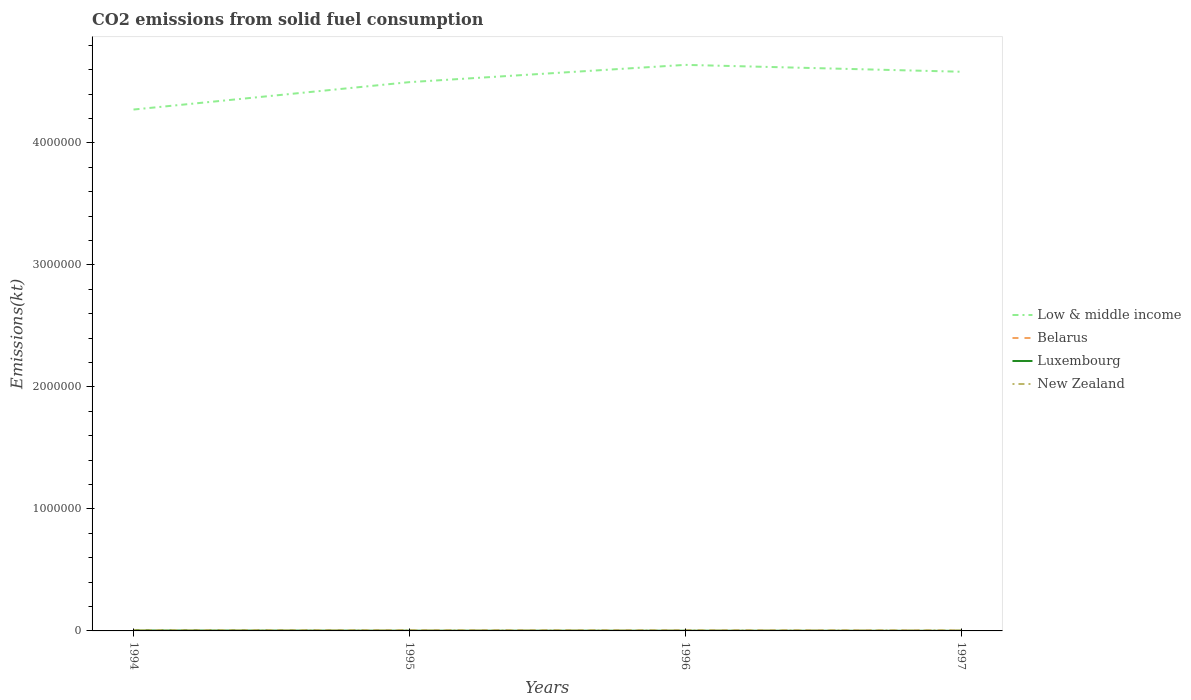Does the line corresponding to Luxembourg intersect with the line corresponding to Belarus?
Ensure brevity in your answer.  No. Across all years, what is the maximum amount of CO2 emitted in Belarus?
Give a very brief answer. 4140.04. In which year was the amount of CO2 emitted in Belarus maximum?
Provide a succinct answer. 1997. What is the total amount of CO2 emitted in Low & middle income in the graph?
Keep it short and to the point. -3.10e+05. What is the difference between the highest and the second highest amount of CO2 emitted in Belarus?
Keep it short and to the point. 1789.5. How many lines are there?
Give a very brief answer. 4. How many years are there in the graph?
Keep it short and to the point. 4. What is the difference between two consecutive major ticks on the Y-axis?
Ensure brevity in your answer.  1.00e+06. Are the values on the major ticks of Y-axis written in scientific E-notation?
Make the answer very short. No. How many legend labels are there?
Your answer should be very brief. 4. What is the title of the graph?
Your answer should be compact. CO2 emissions from solid fuel consumption. Does "Gabon" appear as one of the legend labels in the graph?
Make the answer very short. No. What is the label or title of the X-axis?
Give a very brief answer. Years. What is the label or title of the Y-axis?
Your answer should be compact. Emissions(kt). What is the Emissions(kt) of Low & middle income in 1994?
Provide a succinct answer. 4.27e+06. What is the Emissions(kt) in Belarus in 1994?
Provide a short and direct response. 5929.54. What is the Emissions(kt) of Luxembourg in 1994?
Provide a short and direct response. 3432.31. What is the Emissions(kt) in New Zealand in 1994?
Offer a very short reply. 4602.09. What is the Emissions(kt) in Low & middle income in 1995?
Provide a succinct answer. 4.50e+06. What is the Emissions(kt) in Belarus in 1995?
Keep it short and to the point. 5291.48. What is the Emissions(kt) of Luxembourg in 1995?
Your answer should be very brief. 1947.18. What is the Emissions(kt) of New Zealand in 1995?
Provide a succinct answer. 4462.74. What is the Emissions(kt) of Low & middle income in 1996?
Ensure brevity in your answer.  4.64e+06. What is the Emissions(kt) in Belarus in 1996?
Your answer should be very brief. 5038.46. What is the Emissions(kt) of Luxembourg in 1996?
Offer a terse response. 1840.83. What is the Emissions(kt) of New Zealand in 1996?
Ensure brevity in your answer.  3652.33. What is the Emissions(kt) in Low & middle income in 1997?
Your answer should be compact. 4.58e+06. What is the Emissions(kt) of Belarus in 1997?
Your answer should be very brief. 4140.04. What is the Emissions(kt) of Luxembourg in 1997?
Keep it short and to the point. 1184.44. What is the Emissions(kt) in New Zealand in 1997?
Offer a terse response. 4543.41. Across all years, what is the maximum Emissions(kt) in Low & middle income?
Give a very brief answer. 4.64e+06. Across all years, what is the maximum Emissions(kt) in Belarus?
Your answer should be very brief. 5929.54. Across all years, what is the maximum Emissions(kt) of Luxembourg?
Offer a terse response. 3432.31. Across all years, what is the maximum Emissions(kt) of New Zealand?
Your response must be concise. 4602.09. Across all years, what is the minimum Emissions(kt) in Low & middle income?
Ensure brevity in your answer.  4.27e+06. Across all years, what is the minimum Emissions(kt) of Belarus?
Your answer should be very brief. 4140.04. Across all years, what is the minimum Emissions(kt) in Luxembourg?
Provide a short and direct response. 1184.44. Across all years, what is the minimum Emissions(kt) of New Zealand?
Provide a short and direct response. 3652.33. What is the total Emissions(kt) of Low & middle income in the graph?
Ensure brevity in your answer.  1.80e+07. What is the total Emissions(kt) of Belarus in the graph?
Your answer should be compact. 2.04e+04. What is the total Emissions(kt) in Luxembourg in the graph?
Provide a short and direct response. 8404.76. What is the total Emissions(kt) in New Zealand in the graph?
Make the answer very short. 1.73e+04. What is the difference between the Emissions(kt) in Low & middle income in 1994 and that in 1995?
Make the answer very short. -2.25e+05. What is the difference between the Emissions(kt) of Belarus in 1994 and that in 1995?
Provide a succinct answer. 638.06. What is the difference between the Emissions(kt) of Luxembourg in 1994 and that in 1995?
Give a very brief answer. 1485.13. What is the difference between the Emissions(kt) of New Zealand in 1994 and that in 1995?
Offer a terse response. 139.35. What is the difference between the Emissions(kt) of Low & middle income in 1994 and that in 1996?
Offer a terse response. -3.66e+05. What is the difference between the Emissions(kt) of Belarus in 1994 and that in 1996?
Your response must be concise. 891.08. What is the difference between the Emissions(kt) of Luxembourg in 1994 and that in 1996?
Your answer should be very brief. 1591.48. What is the difference between the Emissions(kt) of New Zealand in 1994 and that in 1996?
Offer a terse response. 949.75. What is the difference between the Emissions(kt) in Low & middle income in 1994 and that in 1997?
Your answer should be compact. -3.10e+05. What is the difference between the Emissions(kt) in Belarus in 1994 and that in 1997?
Give a very brief answer. 1789.5. What is the difference between the Emissions(kt) of Luxembourg in 1994 and that in 1997?
Offer a very short reply. 2247.87. What is the difference between the Emissions(kt) in New Zealand in 1994 and that in 1997?
Your response must be concise. 58.67. What is the difference between the Emissions(kt) in Low & middle income in 1995 and that in 1996?
Provide a short and direct response. -1.42e+05. What is the difference between the Emissions(kt) of Belarus in 1995 and that in 1996?
Provide a succinct answer. 253.02. What is the difference between the Emissions(kt) in Luxembourg in 1995 and that in 1996?
Your answer should be very brief. 106.34. What is the difference between the Emissions(kt) of New Zealand in 1995 and that in 1996?
Provide a short and direct response. 810.41. What is the difference between the Emissions(kt) in Low & middle income in 1995 and that in 1997?
Your answer should be very brief. -8.53e+04. What is the difference between the Emissions(kt) of Belarus in 1995 and that in 1997?
Offer a terse response. 1151.44. What is the difference between the Emissions(kt) in Luxembourg in 1995 and that in 1997?
Provide a succinct answer. 762.74. What is the difference between the Emissions(kt) of New Zealand in 1995 and that in 1997?
Make the answer very short. -80.67. What is the difference between the Emissions(kt) in Low & middle income in 1996 and that in 1997?
Offer a very short reply. 5.63e+04. What is the difference between the Emissions(kt) of Belarus in 1996 and that in 1997?
Provide a succinct answer. 898.41. What is the difference between the Emissions(kt) of Luxembourg in 1996 and that in 1997?
Give a very brief answer. 656.39. What is the difference between the Emissions(kt) of New Zealand in 1996 and that in 1997?
Your answer should be compact. -891.08. What is the difference between the Emissions(kt) of Low & middle income in 1994 and the Emissions(kt) of Belarus in 1995?
Offer a terse response. 4.27e+06. What is the difference between the Emissions(kt) in Low & middle income in 1994 and the Emissions(kt) in Luxembourg in 1995?
Ensure brevity in your answer.  4.27e+06. What is the difference between the Emissions(kt) of Low & middle income in 1994 and the Emissions(kt) of New Zealand in 1995?
Keep it short and to the point. 4.27e+06. What is the difference between the Emissions(kt) of Belarus in 1994 and the Emissions(kt) of Luxembourg in 1995?
Keep it short and to the point. 3982.36. What is the difference between the Emissions(kt) in Belarus in 1994 and the Emissions(kt) in New Zealand in 1995?
Give a very brief answer. 1466.8. What is the difference between the Emissions(kt) of Luxembourg in 1994 and the Emissions(kt) of New Zealand in 1995?
Offer a very short reply. -1030.43. What is the difference between the Emissions(kt) of Low & middle income in 1994 and the Emissions(kt) of Belarus in 1996?
Ensure brevity in your answer.  4.27e+06. What is the difference between the Emissions(kt) in Low & middle income in 1994 and the Emissions(kt) in Luxembourg in 1996?
Provide a short and direct response. 4.27e+06. What is the difference between the Emissions(kt) of Low & middle income in 1994 and the Emissions(kt) of New Zealand in 1996?
Your response must be concise. 4.27e+06. What is the difference between the Emissions(kt) in Belarus in 1994 and the Emissions(kt) in Luxembourg in 1996?
Your response must be concise. 4088.7. What is the difference between the Emissions(kt) in Belarus in 1994 and the Emissions(kt) in New Zealand in 1996?
Ensure brevity in your answer.  2277.21. What is the difference between the Emissions(kt) of Luxembourg in 1994 and the Emissions(kt) of New Zealand in 1996?
Provide a short and direct response. -220.02. What is the difference between the Emissions(kt) of Low & middle income in 1994 and the Emissions(kt) of Belarus in 1997?
Offer a very short reply. 4.27e+06. What is the difference between the Emissions(kt) of Low & middle income in 1994 and the Emissions(kt) of Luxembourg in 1997?
Offer a very short reply. 4.27e+06. What is the difference between the Emissions(kt) in Low & middle income in 1994 and the Emissions(kt) in New Zealand in 1997?
Give a very brief answer. 4.27e+06. What is the difference between the Emissions(kt) in Belarus in 1994 and the Emissions(kt) in Luxembourg in 1997?
Your response must be concise. 4745.1. What is the difference between the Emissions(kt) of Belarus in 1994 and the Emissions(kt) of New Zealand in 1997?
Provide a succinct answer. 1386.13. What is the difference between the Emissions(kt) in Luxembourg in 1994 and the Emissions(kt) in New Zealand in 1997?
Ensure brevity in your answer.  -1111.1. What is the difference between the Emissions(kt) in Low & middle income in 1995 and the Emissions(kt) in Belarus in 1996?
Offer a terse response. 4.49e+06. What is the difference between the Emissions(kt) of Low & middle income in 1995 and the Emissions(kt) of Luxembourg in 1996?
Provide a succinct answer. 4.50e+06. What is the difference between the Emissions(kt) in Low & middle income in 1995 and the Emissions(kt) in New Zealand in 1996?
Provide a succinct answer. 4.49e+06. What is the difference between the Emissions(kt) of Belarus in 1995 and the Emissions(kt) of Luxembourg in 1996?
Give a very brief answer. 3450.65. What is the difference between the Emissions(kt) of Belarus in 1995 and the Emissions(kt) of New Zealand in 1996?
Provide a succinct answer. 1639.15. What is the difference between the Emissions(kt) of Luxembourg in 1995 and the Emissions(kt) of New Zealand in 1996?
Make the answer very short. -1705.15. What is the difference between the Emissions(kt) in Low & middle income in 1995 and the Emissions(kt) in Belarus in 1997?
Offer a terse response. 4.49e+06. What is the difference between the Emissions(kt) in Low & middle income in 1995 and the Emissions(kt) in Luxembourg in 1997?
Offer a very short reply. 4.50e+06. What is the difference between the Emissions(kt) of Low & middle income in 1995 and the Emissions(kt) of New Zealand in 1997?
Offer a terse response. 4.49e+06. What is the difference between the Emissions(kt) in Belarus in 1995 and the Emissions(kt) in Luxembourg in 1997?
Make the answer very short. 4107.04. What is the difference between the Emissions(kt) of Belarus in 1995 and the Emissions(kt) of New Zealand in 1997?
Your answer should be compact. 748.07. What is the difference between the Emissions(kt) of Luxembourg in 1995 and the Emissions(kt) of New Zealand in 1997?
Provide a succinct answer. -2596.24. What is the difference between the Emissions(kt) of Low & middle income in 1996 and the Emissions(kt) of Belarus in 1997?
Keep it short and to the point. 4.64e+06. What is the difference between the Emissions(kt) in Low & middle income in 1996 and the Emissions(kt) in Luxembourg in 1997?
Offer a very short reply. 4.64e+06. What is the difference between the Emissions(kt) of Low & middle income in 1996 and the Emissions(kt) of New Zealand in 1997?
Make the answer very short. 4.63e+06. What is the difference between the Emissions(kt) in Belarus in 1996 and the Emissions(kt) in Luxembourg in 1997?
Your response must be concise. 3854.02. What is the difference between the Emissions(kt) in Belarus in 1996 and the Emissions(kt) in New Zealand in 1997?
Your answer should be very brief. 495.05. What is the difference between the Emissions(kt) in Luxembourg in 1996 and the Emissions(kt) in New Zealand in 1997?
Make the answer very short. -2702.58. What is the average Emissions(kt) of Low & middle income per year?
Offer a terse response. 4.50e+06. What is the average Emissions(kt) of Belarus per year?
Keep it short and to the point. 5099.88. What is the average Emissions(kt) of Luxembourg per year?
Offer a terse response. 2101.19. What is the average Emissions(kt) in New Zealand per year?
Keep it short and to the point. 4315.14. In the year 1994, what is the difference between the Emissions(kt) of Low & middle income and Emissions(kt) of Belarus?
Your response must be concise. 4.27e+06. In the year 1994, what is the difference between the Emissions(kt) in Low & middle income and Emissions(kt) in Luxembourg?
Offer a terse response. 4.27e+06. In the year 1994, what is the difference between the Emissions(kt) of Low & middle income and Emissions(kt) of New Zealand?
Your response must be concise. 4.27e+06. In the year 1994, what is the difference between the Emissions(kt) in Belarus and Emissions(kt) in Luxembourg?
Give a very brief answer. 2497.23. In the year 1994, what is the difference between the Emissions(kt) in Belarus and Emissions(kt) in New Zealand?
Offer a very short reply. 1327.45. In the year 1994, what is the difference between the Emissions(kt) in Luxembourg and Emissions(kt) in New Zealand?
Offer a terse response. -1169.77. In the year 1995, what is the difference between the Emissions(kt) in Low & middle income and Emissions(kt) in Belarus?
Your answer should be very brief. 4.49e+06. In the year 1995, what is the difference between the Emissions(kt) in Low & middle income and Emissions(kt) in Luxembourg?
Make the answer very short. 4.50e+06. In the year 1995, what is the difference between the Emissions(kt) in Low & middle income and Emissions(kt) in New Zealand?
Offer a terse response. 4.49e+06. In the year 1995, what is the difference between the Emissions(kt) of Belarus and Emissions(kt) of Luxembourg?
Give a very brief answer. 3344.3. In the year 1995, what is the difference between the Emissions(kt) of Belarus and Emissions(kt) of New Zealand?
Ensure brevity in your answer.  828.74. In the year 1995, what is the difference between the Emissions(kt) in Luxembourg and Emissions(kt) in New Zealand?
Provide a short and direct response. -2515.56. In the year 1996, what is the difference between the Emissions(kt) of Low & middle income and Emissions(kt) of Belarus?
Offer a very short reply. 4.63e+06. In the year 1996, what is the difference between the Emissions(kt) of Low & middle income and Emissions(kt) of Luxembourg?
Offer a terse response. 4.64e+06. In the year 1996, what is the difference between the Emissions(kt) in Low & middle income and Emissions(kt) in New Zealand?
Ensure brevity in your answer.  4.64e+06. In the year 1996, what is the difference between the Emissions(kt) of Belarus and Emissions(kt) of Luxembourg?
Offer a very short reply. 3197.62. In the year 1996, what is the difference between the Emissions(kt) in Belarus and Emissions(kt) in New Zealand?
Keep it short and to the point. 1386.13. In the year 1996, what is the difference between the Emissions(kt) in Luxembourg and Emissions(kt) in New Zealand?
Ensure brevity in your answer.  -1811.5. In the year 1997, what is the difference between the Emissions(kt) of Low & middle income and Emissions(kt) of Belarus?
Offer a terse response. 4.58e+06. In the year 1997, what is the difference between the Emissions(kt) in Low & middle income and Emissions(kt) in Luxembourg?
Give a very brief answer. 4.58e+06. In the year 1997, what is the difference between the Emissions(kt) in Low & middle income and Emissions(kt) in New Zealand?
Give a very brief answer. 4.58e+06. In the year 1997, what is the difference between the Emissions(kt) in Belarus and Emissions(kt) in Luxembourg?
Your response must be concise. 2955.6. In the year 1997, what is the difference between the Emissions(kt) of Belarus and Emissions(kt) of New Zealand?
Provide a succinct answer. -403.37. In the year 1997, what is the difference between the Emissions(kt) in Luxembourg and Emissions(kt) in New Zealand?
Provide a short and direct response. -3358.97. What is the ratio of the Emissions(kt) of Low & middle income in 1994 to that in 1995?
Offer a very short reply. 0.95. What is the ratio of the Emissions(kt) of Belarus in 1994 to that in 1995?
Your response must be concise. 1.12. What is the ratio of the Emissions(kt) in Luxembourg in 1994 to that in 1995?
Your answer should be very brief. 1.76. What is the ratio of the Emissions(kt) of New Zealand in 1994 to that in 1995?
Provide a succinct answer. 1.03. What is the ratio of the Emissions(kt) of Low & middle income in 1994 to that in 1996?
Your response must be concise. 0.92. What is the ratio of the Emissions(kt) in Belarus in 1994 to that in 1996?
Your response must be concise. 1.18. What is the ratio of the Emissions(kt) of Luxembourg in 1994 to that in 1996?
Your response must be concise. 1.86. What is the ratio of the Emissions(kt) in New Zealand in 1994 to that in 1996?
Your response must be concise. 1.26. What is the ratio of the Emissions(kt) of Low & middle income in 1994 to that in 1997?
Provide a short and direct response. 0.93. What is the ratio of the Emissions(kt) of Belarus in 1994 to that in 1997?
Give a very brief answer. 1.43. What is the ratio of the Emissions(kt) in Luxembourg in 1994 to that in 1997?
Keep it short and to the point. 2.9. What is the ratio of the Emissions(kt) in New Zealand in 1994 to that in 1997?
Offer a very short reply. 1.01. What is the ratio of the Emissions(kt) in Low & middle income in 1995 to that in 1996?
Make the answer very short. 0.97. What is the ratio of the Emissions(kt) of Belarus in 1995 to that in 1996?
Provide a succinct answer. 1.05. What is the ratio of the Emissions(kt) in Luxembourg in 1995 to that in 1996?
Make the answer very short. 1.06. What is the ratio of the Emissions(kt) in New Zealand in 1995 to that in 1996?
Keep it short and to the point. 1.22. What is the ratio of the Emissions(kt) in Low & middle income in 1995 to that in 1997?
Your response must be concise. 0.98. What is the ratio of the Emissions(kt) of Belarus in 1995 to that in 1997?
Your answer should be compact. 1.28. What is the ratio of the Emissions(kt) of Luxembourg in 1995 to that in 1997?
Keep it short and to the point. 1.64. What is the ratio of the Emissions(kt) in New Zealand in 1995 to that in 1997?
Your answer should be compact. 0.98. What is the ratio of the Emissions(kt) in Low & middle income in 1996 to that in 1997?
Offer a terse response. 1.01. What is the ratio of the Emissions(kt) in Belarus in 1996 to that in 1997?
Provide a short and direct response. 1.22. What is the ratio of the Emissions(kt) in Luxembourg in 1996 to that in 1997?
Offer a very short reply. 1.55. What is the ratio of the Emissions(kt) in New Zealand in 1996 to that in 1997?
Make the answer very short. 0.8. What is the difference between the highest and the second highest Emissions(kt) of Low & middle income?
Your response must be concise. 5.63e+04. What is the difference between the highest and the second highest Emissions(kt) of Belarus?
Provide a short and direct response. 638.06. What is the difference between the highest and the second highest Emissions(kt) in Luxembourg?
Offer a very short reply. 1485.13. What is the difference between the highest and the second highest Emissions(kt) of New Zealand?
Offer a very short reply. 58.67. What is the difference between the highest and the lowest Emissions(kt) in Low & middle income?
Keep it short and to the point. 3.66e+05. What is the difference between the highest and the lowest Emissions(kt) in Belarus?
Make the answer very short. 1789.5. What is the difference between the highest and the lowest Emissions(kt) in Luxembourg?
Your answer should be compact. 2247.87. What is the difference between the highest and the lowest Emissions(kt) of New Zealand?
Keep it short and to the point. 949.75. 